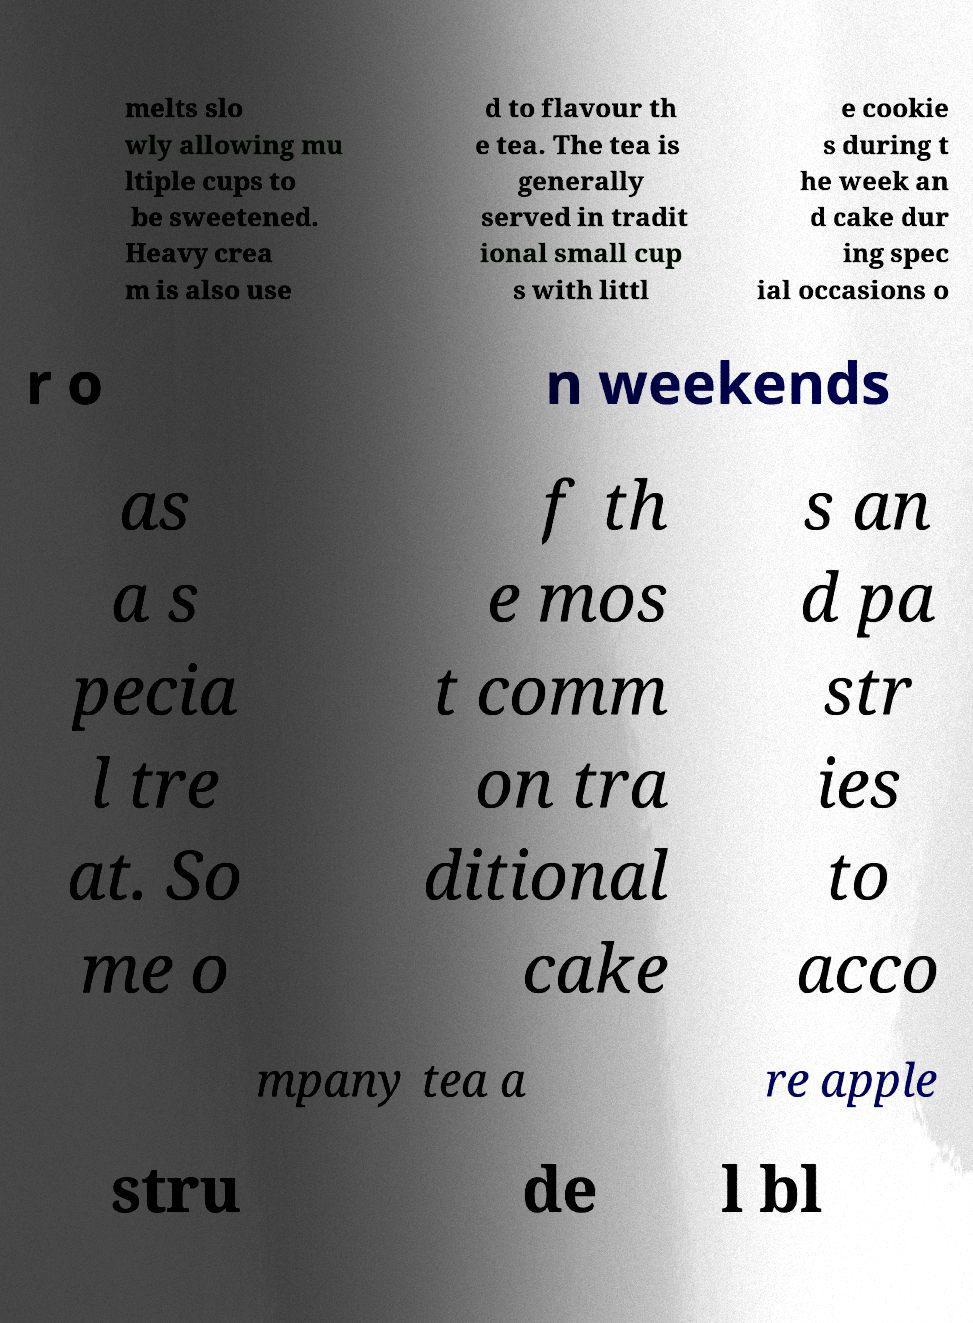I need the written content from this picture converted into text. Can you do that? melts slo wly allowing mu ltiple cups to be sweetened. Heavy crea m is also use d to flavour th e tea. The tea is generally served in tradit ional small cup s with littl e cookie s during t he week an d cake dur ing spec ial occasions o r o n weekends as a s pecia l tre at. So me o f th e mos t comm on tra ditional cake s an d pa str ies to acco mpany tea a re apple stru de l bl 